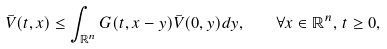<formula> <loc_0><loc_0><loc_500><loc_500>\bar { V } ( t , x ) \leq \int _ { \mathbb { R } ^ { n } } G ( t , x - y ) \bar { V } ( 0 , y ) d y , \quad \forall x \in \mathbb { R } ^ { n } , \, t \geq 0 ,</formula> 